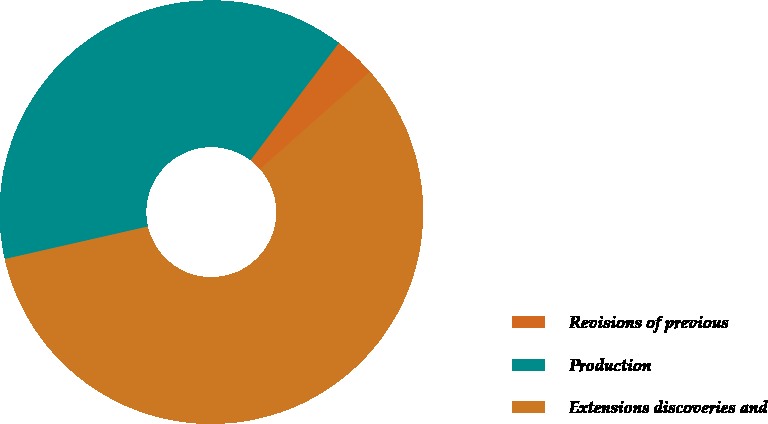Convert chart. <chart><loc_0><loc_0><loc_500><loc_500><pie_chart><fcel>Revisions of previous<fcel>Production<fcel>Extensions discoveries and<nl><fcel>3.19%<fcel>38.84%<fcel>57.98%<nl></chart> 